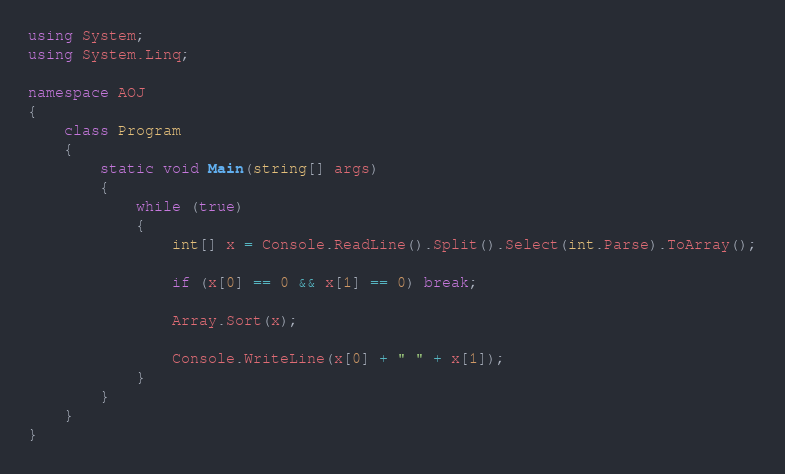<code> <loc_0><loc_0><loc_500><loc_500><_C#_>using System;
using System.Linq;

namespace AOJ
{
    class Program
    {
        static void Main(string[] args)
        {
            while (true)
            {
                int[] x = Console.ReadLine().Split().Select(int.Parse).ToArray();

                if (x[0] == 0 && x[1] == 0) break;

                Array.Sort(x);

                Console.WriteLine(x[0] + " " + x[1]);
            }
        }
    }
}

</code> 